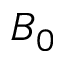<formula> <loc_0><loc_0><loc_500><loc_500>B _ { 0 }</formula> 